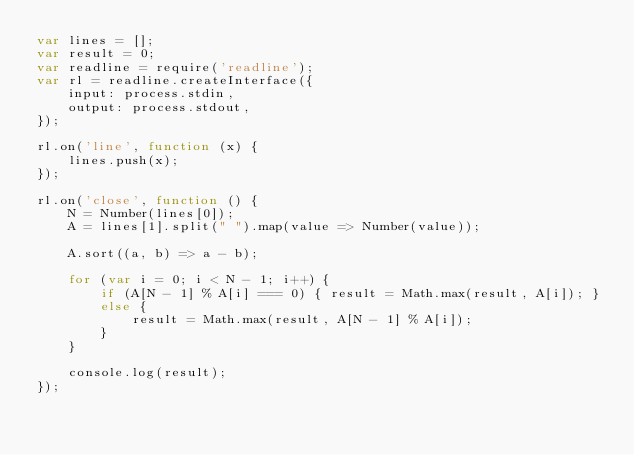Convert code to text. <code><loc_0><loc_0><loc_500><loc_500><_JavaScript_>var lines = [];
var result = 0;
var readline = require('readline');
var rl = readline.createInterface({
    input: process.stdin,
    output: process.stdout,
});

rl.on('line', function (x) {
    lines.push(x);
});

rl.on('close', function () {
    N = Number(lines[0]);
    A = lines[1].split(" ").map(value => Number(value));

    A.sort((a, b) => a - b);

    for (var i = 0; i < N - 1; i++) {
        if (A[N - 1] % A[i] === 0) { result = Math.max(result, A[i]); }
        else {
            result = Math.max(result, A[N - 1] % A[i]);
        }
    }

    console.log(result);
});</code> 